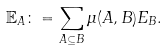<formula> <loc_0><loc_0><loc_500><loc_500>{ } \mathbb { E } _ { A } \colon = \sum _ { A \subseteq B } \mu ( A , B ) E _ { B } .</formula> 